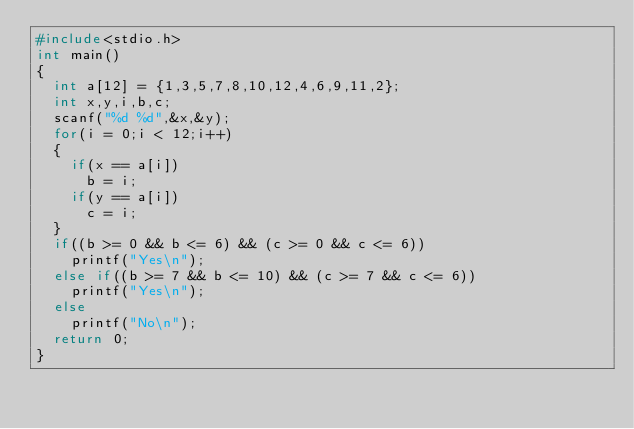<code> <loc_0><loc_0><loc_500><loc_500><_C_>#include<stdio.h>
int main()
{
	int a[12] = {1,3,5,7,8,10,12,4,6,9,11,2};
	int x,y,i,b,c;
	scanf("%d %d",&x,&y);
	for(i = 0;i < 12;i++)
	{
		if(x == a[i])
			b = i;
		if(y == a[i])
			c = i;
	}
	if((b >= 0 && b <= 6) && (c >= 0 && c <= 6))
		printf("Yes\n");
	else if((b >= 7 && b <= 10) && (c >= 7 && c <= 6))
		printf("Yes\n");
	else
		printf("No\n");
	return 0;
}
</code> 